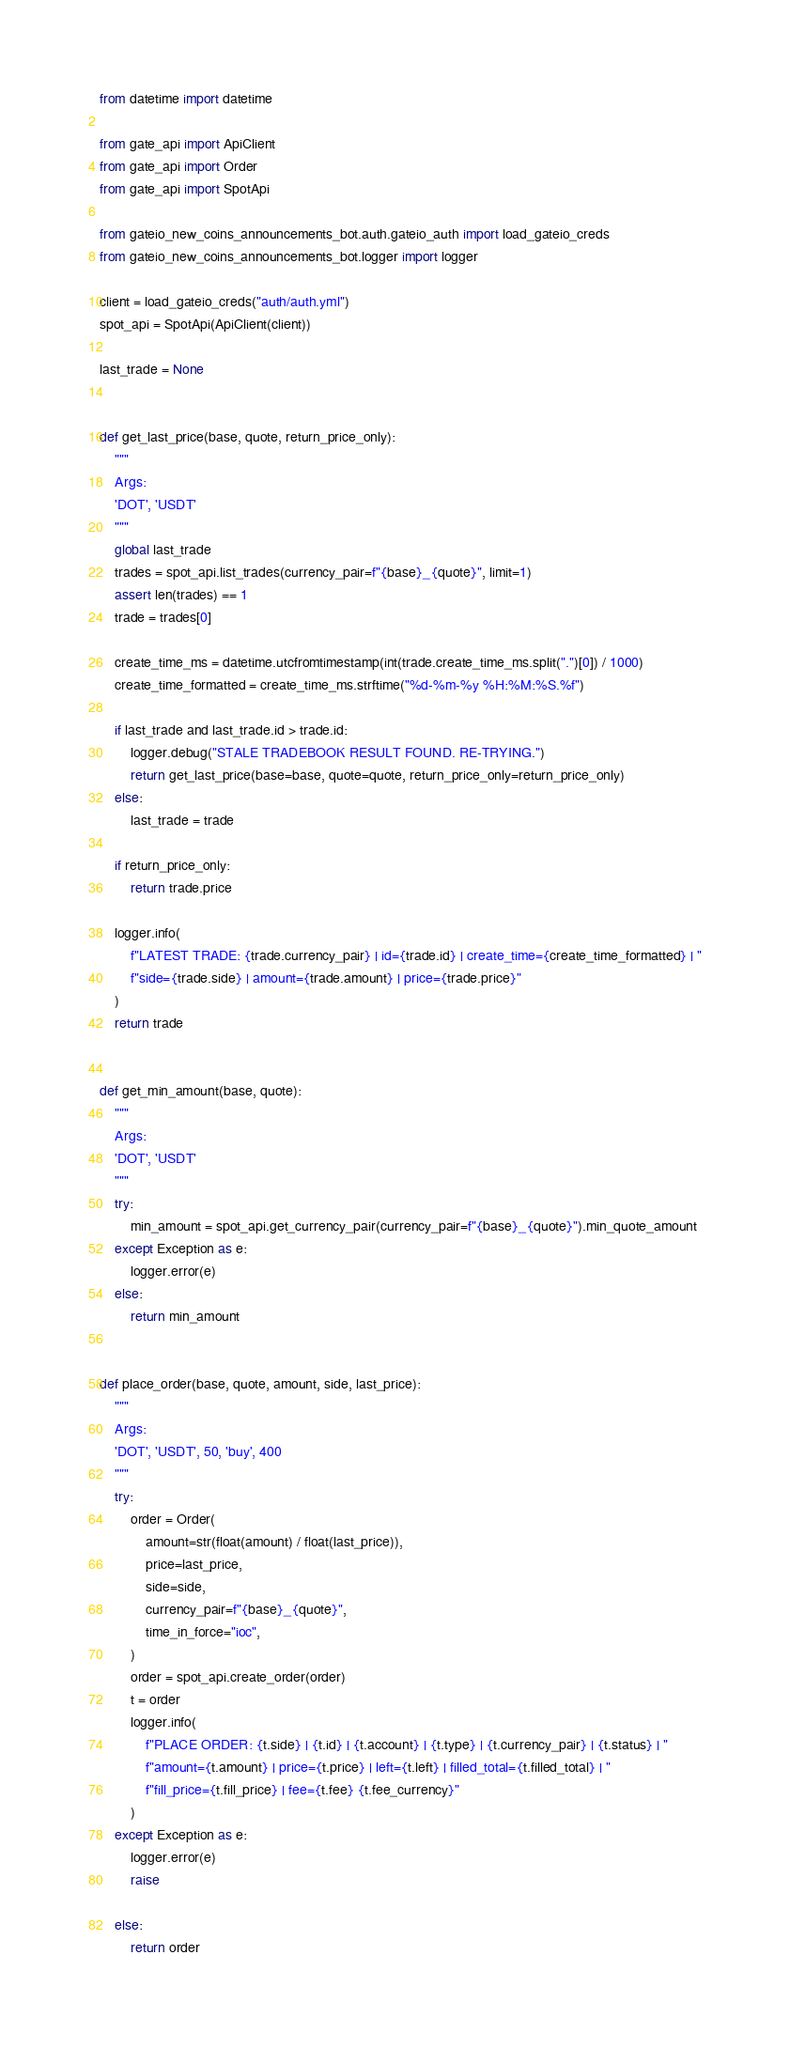Convert code to text. <code><loc_0><loc_0><loc_500><loc_500><_Python_>from datetime import datetime

from gate_api import ApiClient
from gate_api import Order
from gate_api import SpotApi

from gateio_new_coins_announcements_bot.auth.gateio_auth import load_gateio_creds
from gateio_new_coins_announcements_bot.logger import logger

client = load_gateio_creds("auth/auth.yml")
spot_api = SpotApi(ApiClient(client))

last_trade = None


def get_last_price(base, quote, return_price_only):
    """
    Args:
    'DOT', 'USDT'
    """
    global last_trade
    trades = spot_api.list_trades(currency_pair=f"{base}_{quote}", limit=1)
    assert len(trades) == 1
    trade = trades[0]

    create_time_ms = datetime.utcfromtimestamp(int(trade.create_time_ms.split(".")[0]) / 1000)
    create_time_formatted = create_time_ms.strftime("%d-%m-%y %H:%M:%S.%f")

    if last_trade and last_trade.id > trade.id:
        logger.debug("STALE TRADEBOOK RESULT FOUND. RE-TRYING.")
        return get_last_price(base=base, quote=quote, return_price_only=return_price_only)
    else:
        last_trade = trade

    if return_price_only:
        return trade.price

    logger.info(
        f"LATEST TRADE: {trade.currency_pair} | id={trade.id} | create_time={create_time_formatted} | "
        f"side={trade.side} | amount={trade.amount} | price={trade.price}"
    )
    return trade


def get_min_amount(base, quote):
    """
    Args:
    'DOT', 'USDT'
    """
    try:
        min_amount = spot_api.get_currency_pair(currency_pair=f"{base}_{quote}").min_quote_amount
    except Exception as e:
        logger.error(e)
    else:
        return min_amount


def place_order(base, quote, amount, side, last_price):
    """
    Args:
    'DOT', 'USDT', 50, 'buy', 400
    """
    try:
        order = Order(
            amount=str(float(amount) / float(last_price)),
            price=last_price,
            side=side,
            currency_pair=f"{base}_{quote}",
            time_in_force="ioc",
        )
        order = spot_api.create_order(order)
        t = order
        logger.info(
            f"PLACE ORDER: {t.side} | {t.id} | {t.account} | {t.type} | {t.currency_pair} | {t.status} | "
            f"amount={t.amount} | price={t.price} | left={t.left} | filled_total={t.filled_total} | "
            f"fill_price={t.fill_price} | fee={t.fee} {t.fee_currency}"
        )
    except Exception as e:
        logger.error(e)
        raise

    else:
        return order
</code> 